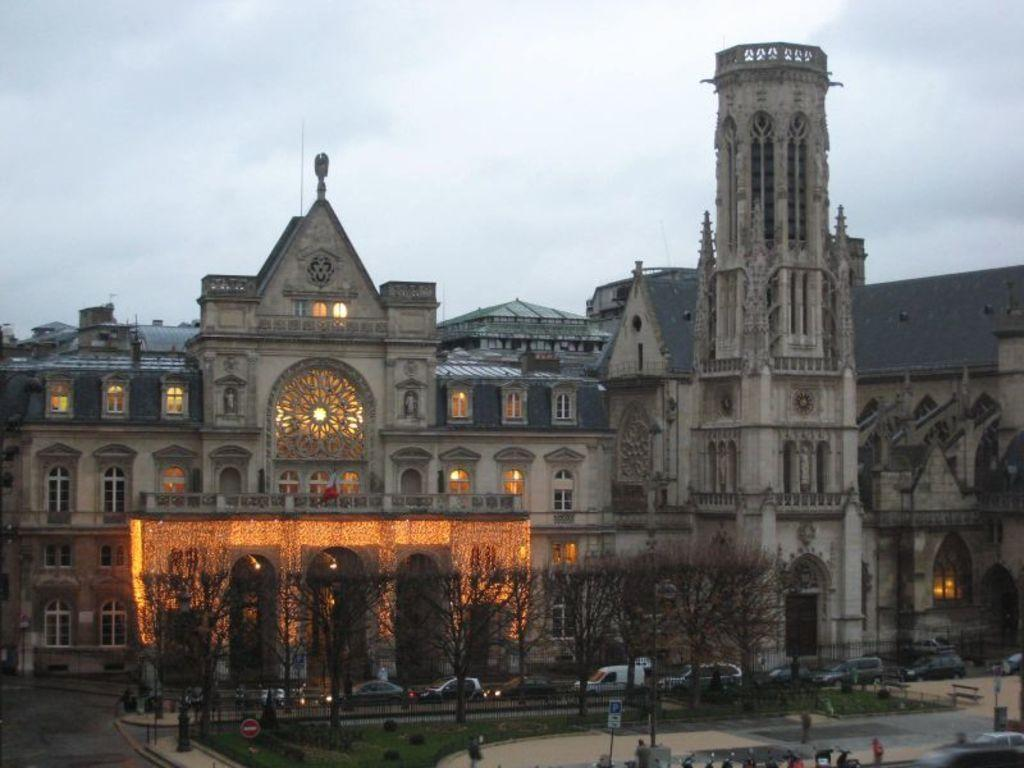What type of structures can be seen in the image? There are buildings in the image. What architectural feature is present in the buildings? There are windows in the image. What type of barrier is present in the image? There is a fence in the image. What type of vegetation is present in the image? There are trees and grass in the image. What type of transportation is present in the image? There are vehicles and motorcycles in the image. What is visible at the top of the image? The sky is visible at the top of the image. How many records can be seen on the ground in the image? There are no records present in the image. What type of animals are grazing in the grass in the image? There are no animals present in the image. 